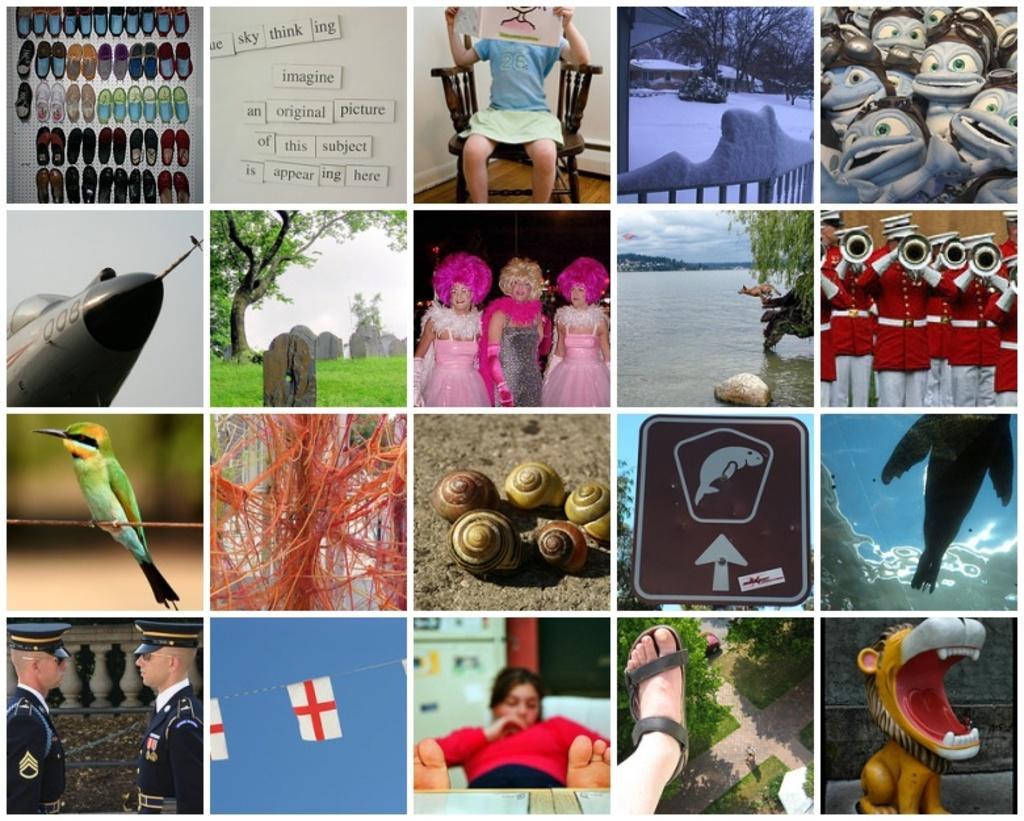Could you give a brief overview of what you see in this image? This image is a collage image of many images. 